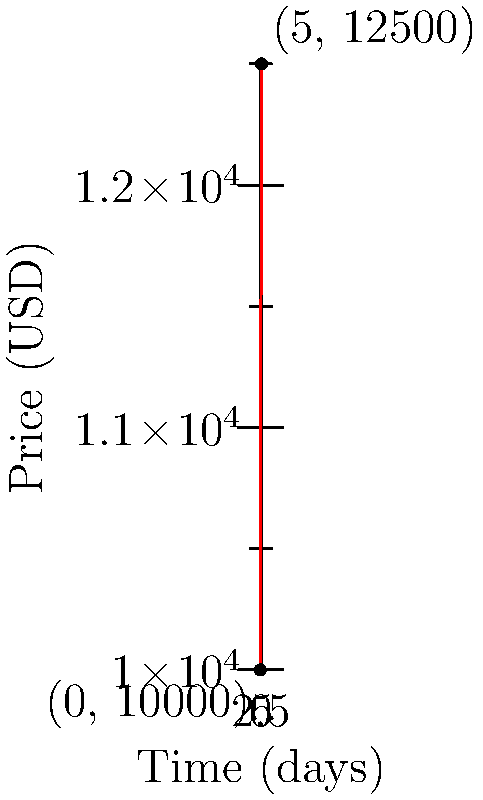As the CEO of a decentralized cryptocurrency exchange, you're analyzing the price trend of a new token listed on your platform. The token price was $10,000 at listing (day 0) and increased to $12,500 after 5 days. Find the equation of the line representing this price trend in the form $y = mx + b$, where $y$ is the price in USD and $x$ is the number of days since listing. To find the equation of the line passing through two points, we'll use the point-slope form and then convert it to slope-intercept form.

Step 1: Identify the two points:
Point 1: $(x_1, y_1) = (0, 10000)$
Point 2: $(x_2, y_2) = (5, 12500)$

Step 2: Calculate the slope (m):
$$m = \frac{y_2 - y_1}{x_2 - x_1} = \frac{12500 - 10000}{5 - 0} = \frac{2500}{5} = 500$$

Step 3: Use the point-slope form with either point. Let's use $(0, 10000)$:
$y - y_1 = m(x - x_1)$
$y - 10000 = 500(x - 0)$

Step 4: Simplify to slope-intercept form $(y = mx + b)$:
$y - 10000 = 500x$
$y = 500x + 10000$

Therefore, the equation of the line representing the price trend is $y = 500x + 10000$, where $y$ is the price in USD and $x$ is the number of days since listing.
Answer: $y = 500x + 10000$ 